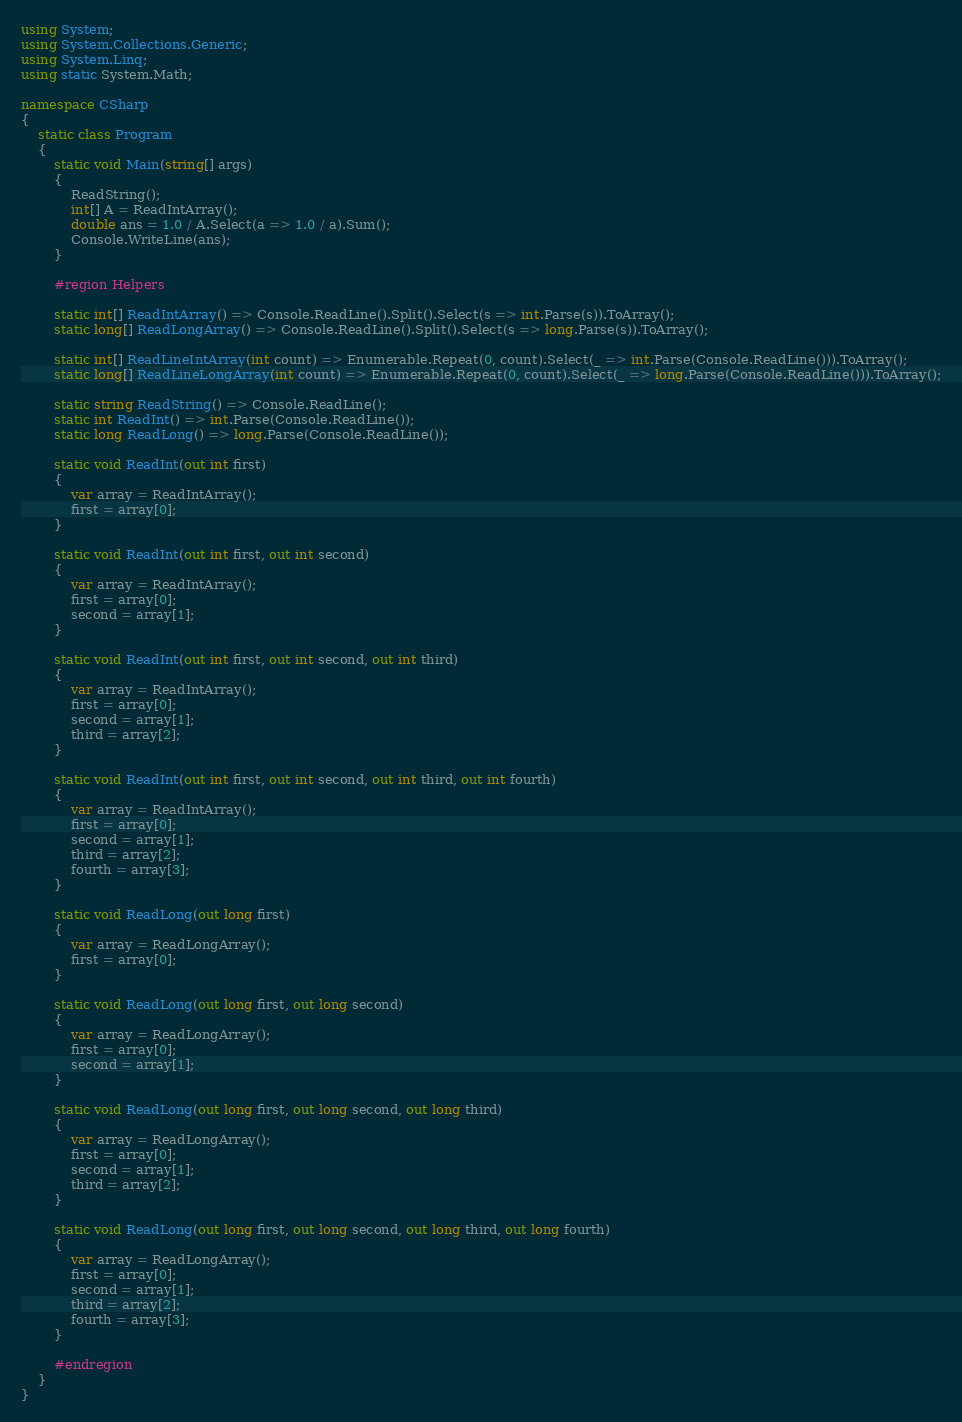<code> <loc_0><loc_0><loc_500><loc_500><_C#_>using System;
using System.Collections.Generic;
using System.Linq;
using static System.Math;

namespace CSharp
{
    static class Program
    {
        static void Main(string[] args)
        {
            ReadString();
            int[] A = ReadIntArray();
            double ans = 1.0 / A.Select(a => 1.0 / a).Sum();
            Console.WriteLine(ans);
        }

        #region Helpers

        static int[] ReadIntArray() => Console.ReadLine().Split().Select(s => int.Parse(s)).ToArray();
        static long[] ReadLongArray() => Console.ReadLine().Split().Select(s => long.Parse(s)).ToArray();

        static int[] ReadLineIntArray(int count) => Enumerable.Repeat(0, count).Select(_ => int.Parse(Console.ReadLine())).ToArray();
        static long[] ReadLineLongArray(int count) => Enumerable.Repeat(0, count).Select(_ => long.Parse(Console.ReadLine())).ToArray();

        static string ReadString() => Console.ReadLine();
        static int ReadInt() => int.Parse(Console.ReadLine());
        static long ReadLong() => long.Parse(Console.ReadLine());

        static void ReadInt(out int first)
        {
            var array = ReadIntArray();
            first = array[0];
        }

        static void ReadInt(out int first, out int second)
        {
            var array = ReadIntArray();
            first = array[0];
            second = array[1];
        }

        static void ReadInt(out int first, out int second, out int third)
        {
            var array = ReadIntArray();
            first = array[0];
            second = array[1];
            third = array[2];
        }

        static void ReadInt(out int first, out int second, out int third, out int fourth)
        {
            var array = ReadIntArray();
            first = array[0];
            second = array[1];
            third = array[2];
            fourth = array[3];
        }

        static void ReadLong(out long first)
        {
            var array = ReadLongArray();
            first = array[0];
        }

        static void ReadLong(out long first, out long second)
        {
            var array = ReadLongArray();
            first = array[0];
            second = array[1];
        }

        static void ReadLong(out long first, out long second, out long third)
        {
            var array = ReadLongArray();
            first = array[0];
            second = array[1];
            third = array[2];
        }

        static void ReadLong(out long first, out long second, out long third, out long fourth)
        {
            var array = ReadLongArray();
            first = array[0];
            second = array[1];
            third = array[2];
            fourth = array[3];
        }

        #endregion
    }
}</code> 